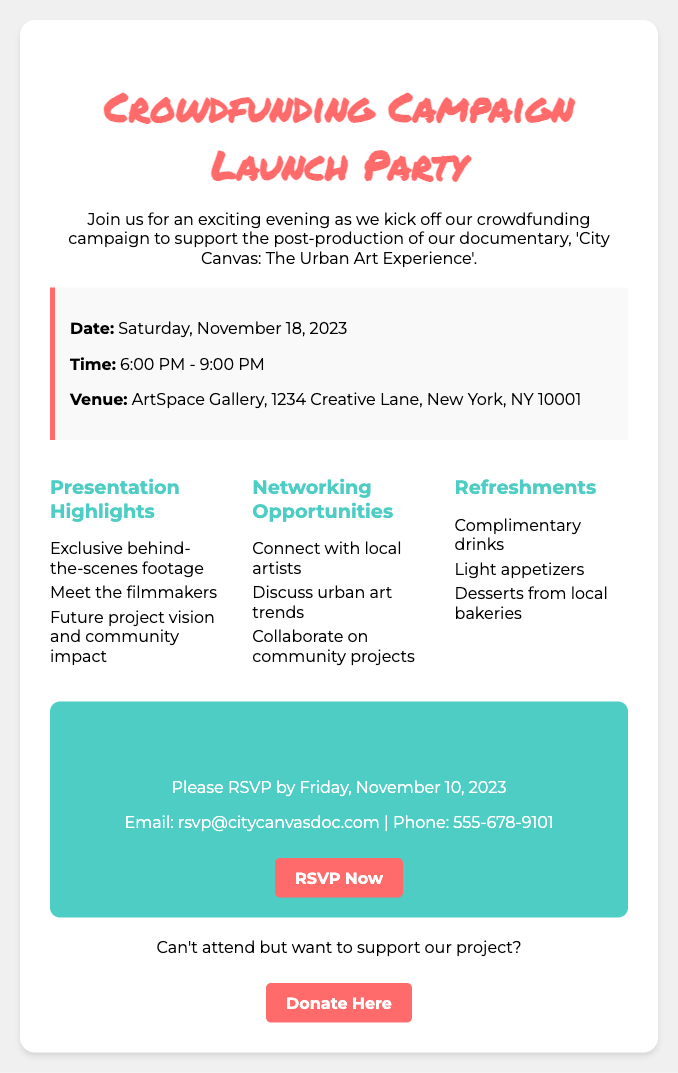What is the event date? The event date is mentioned prominently in the event details section.
Answer: Saturday, November 18, 2023 What time does the event start? The event start time is specified in the same section as the date.
Answer: 6:00 PM Where is the venue located? The venue location is provided in the event details.
Answer: ArtSpace Gallery, 1234 Creative Lane, New York, NY 10001 What is the email for RSVPs? The email for RSVPs is listed in the RSVP details section.
Answer: rsvp@citycanvasdoc.com What are the presentation highlights about? The presentation highlights summarize key topics discussed at the event that can be found in the highlights section.
Answer: Exclusive behind-the-scenes footage How many networking opportunities are listed? The number of networking opportunities can be counted from the list provided in the highlights section.
Answer: Three What type of refreshments will be served? The type of refreshments are outlined in the refreshment section.
Answer: Complimentary drinks When is the RSVP deadline? The RSVP deadline is stated clearly in the RSVP details section.
Answer: Friday, November 10, 2023 Can I still donate if I can't attend? The document mentions additional ways to support the project if unable to attend, implying donations are accepted.
Answer: Yes 